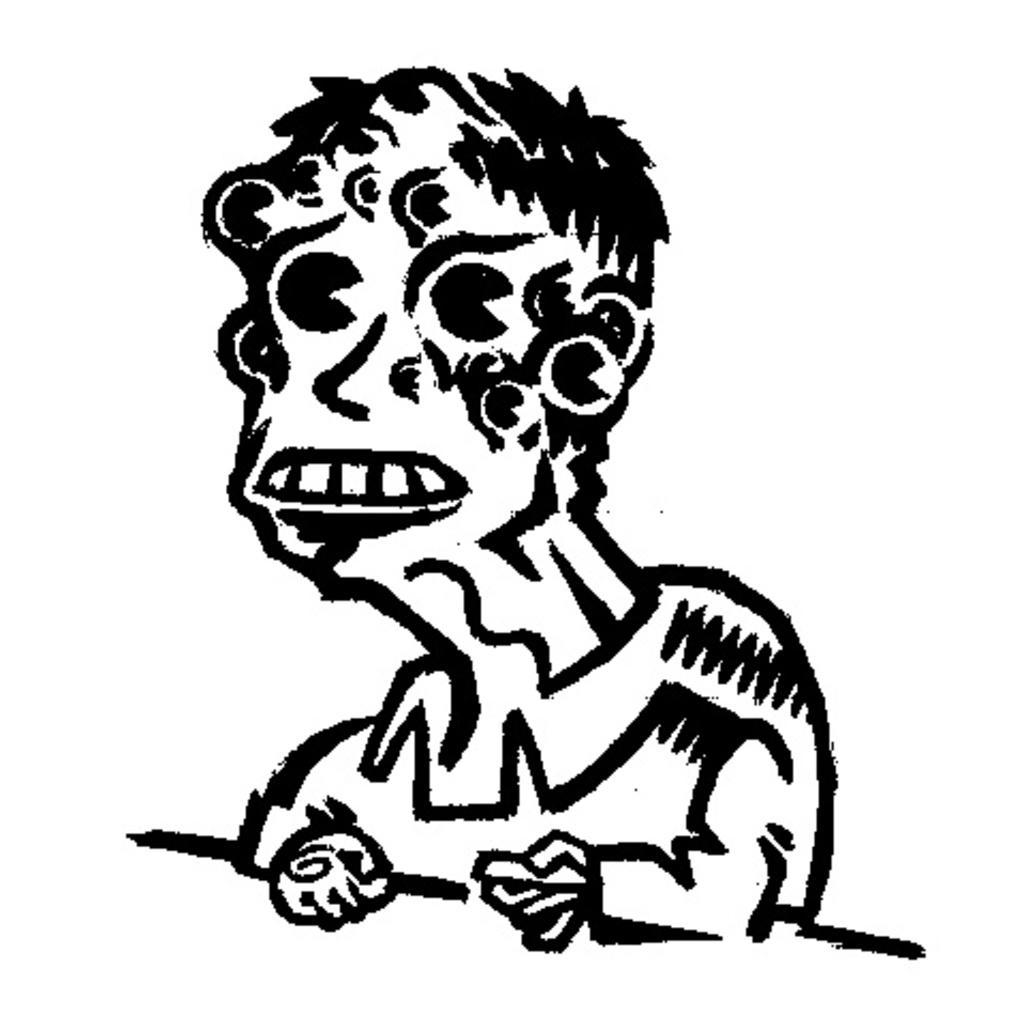Please provide a concise description of this image. In this image I can see a drawing. I can also see this image is black and white in colour. 